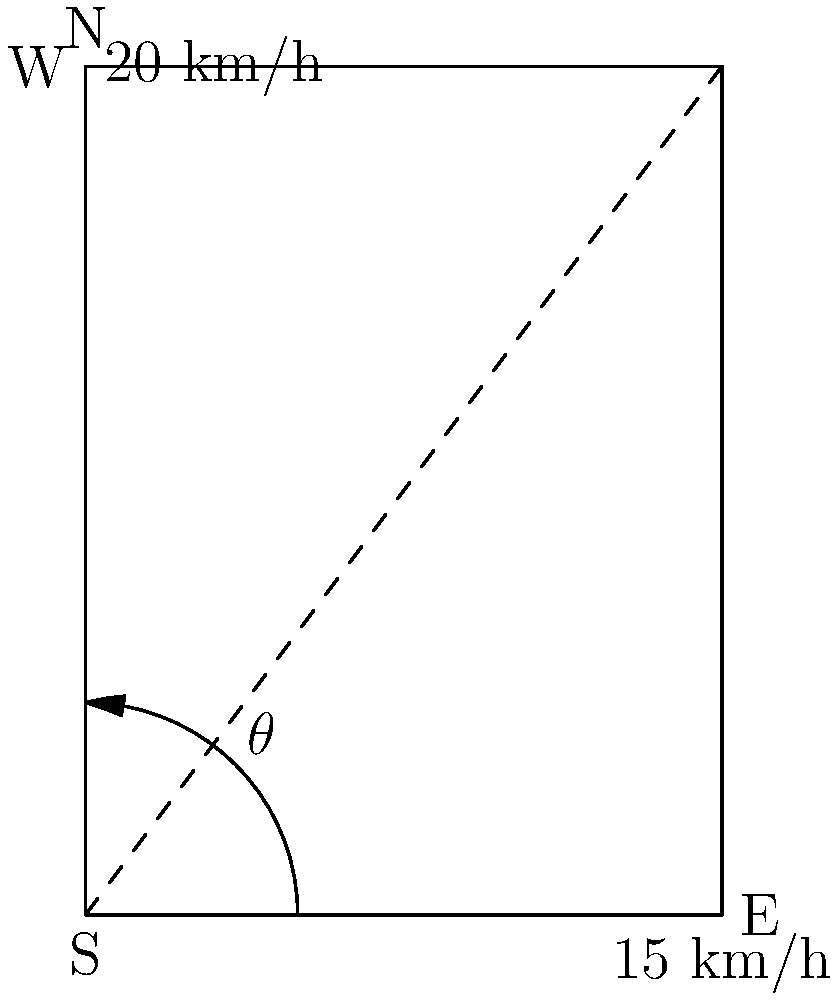As a local resident observing weather patterns, you notice two winds affecting your area. An easterly wind blows at 15 km/h, while a northerly wind blows at 20 km/h. What is the speed of the resultant wind to the nearest km/h, and at what angle $\theta$ (to the nearest degree) does it blow relative to due east? To solve this problem, we'll use vector addition and the Pythagorean theorem:

1) Let's represent the easterly wind as vector $\vec{a} = (15, 0)$ and the northerly wind as vector $\vec{b} = (0, 20)$.

2) The resultant wind vector $\vec{r}$ is the sum of these vectors: $\vec{r} = \vec{a} + \vec{b} = (15, 20)$.

3) To find the speed of the resultant wind, we calculate the magnitude of $\vec{r}$:

   $|\vec{r}| = \sqrt{15^2 + 20^2} = \sqrt{225 + 400} = \sqrt{625} = 25$ km/h

4) To find the angle $\theta$, we use the arctangent function:

   $\theta = \arctan(\frac{20}{15}) \approx 53.13°$

5) Rounding to the nearest whole number:
   Speed ≈ 25 km/h
   Angle $\theta$ ≈ 53°

Therefore, the resultant wind blows at approximately 25 km/h at an angle of 53° relative to due east.
Answer: 25 km/h, 53° 